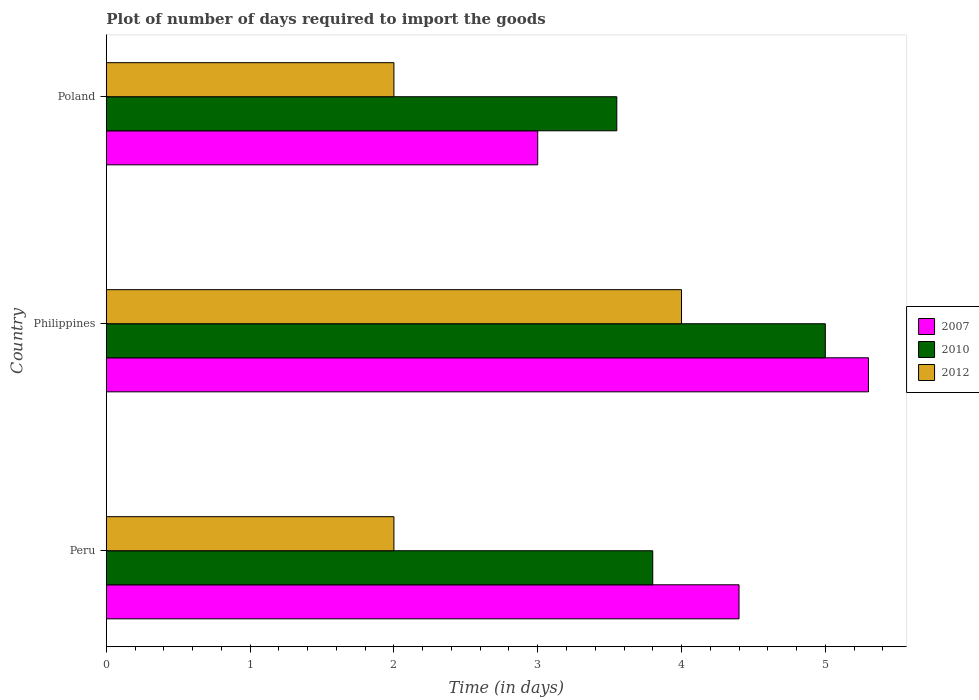How many different coloured bars are there?
Offer a terse response. 3. Are the number of bars per tick equal to the number of legend labels?
Your response must be concise. Yes. Are the number of bars on each tick of the Y-axis equal?
Your answer should be compact. Yes. What is the label of the 2nd group of bars from the top?
Offer a terse response. Philippines. Across all countries, what is the minimum time required to import goods in 2012?
Offer a terse response. 2. In which country was the time required to import goods in 2012 maximum?
Provide a succinct answer. Philippines. In which country was the time required to import goods in 2012 minimum?
Keep it short and to the point. Peru. What is the total time required to import goods in 2010 in the graph?
Your answer should be compact. 12.35. What is the difference between the time required to import goods in 2010 in Philippines and that in Poland?
Keep it short and to the point. 1.45. What is the average time required to import goods in 2012 per country?
Ensure brevity in your answer.  2.67. What is the difference between the time required to import goods in 2007 and time required to import goods in 2010 in Poland?
Your answer should be compact. -0.55. Is the difference between the time required to import goods in 2007 in Philippines and Poland greater than the difference between the time required to import goods in 2010 in Philippines and Poland?
Your answer should be very brief. Yes. What is the difference between the highest and the second highest time required to import goods in 2012?
Your answer should be compact. 2. What is the difference between the highest and the lowest time required to import goods in 2010?
Keep it short and to the point. 1.45. In how many countries, is the time required to import goods in 2012 greater than the average time required to import goods in 2012 taken over all countries?
Make the answer very short. 1. Is the sum of the time required to import goods in 2012 in Peru and Philippines greater than the maximum time required to import goods in 2010 across all countries?
Make the answer very short. Yes. What does the 1st bar from the bottom in Peru represents?
Your answer should be compact. 2007. Is it the case that in every country, the sum of the time required to import goods in 2012 and time required to import goods in 2007 is greater than the time required to import goods in 2010?
Offer a terse response. Yes. How many bars are there?
Give a very brief answer. 9. What is the difference between two consecutive major ticks on the X-axis?
Keep it short and to the point. 1. Are the values on the major ticks of X-axis written in scientific E-notation?
Your answer should be compact. No. How many legend labels are there?
Offer a very short reply. 3. How are the legend labels stacked?
Keep it short and to the point. Vertical. What is the title of the graph?
Your answer should be compact. Plot of number of days required to import the goods. Does "1980" appear as one of the legend labels in the graph?
Your response must be concise. No. What is the label or title of the X-axis?
Keep it short and to the point. Time (in days). What is the Time (in days) in 2012 in Peru?
Offer a very short reply. 2. What is the Time (in days) of 2010 in Philippines?
Keep it short and to the point. 5. What is the Time (in days) in 2007 in Poland?
Ensure brevity in your answer.  3. What is the Time (in days) in 2010 in Poland?
Provide a succinct answer. 3.55. What is the Time (in days) of 2012 in Poland?
Your answer should be very brief. 2. Across all countries, what is the maximum Time (in days) of 2007?
Provide a short and direct response. 5.3. Across all countries, what is the maximum Time (in days) of 2010?
Your response must be concise. 5. Across all countries, what is the maximum Time (in days) in 2012?
Ensure brevity in your answer.  4. Across all countries, what is the minimum Time (in days) of 2010?
Your answer should be very brief. 3.55. Across all countries, what is the minimum Time (in days) of 2012?
Ensure brevity in your answer.  2. What is the total Time (in days) in 2007 in the graph?
Keep it short and to the point. 12.7. What is the total Time (in days) of 2010 in the graph?
Offer a very short reply. 12.35. What is the total Time (in days) of 2012 in the graph?
Make the answer very short. 8. What is the difference between the Time (in days) of 2010 in Peru and that in Philippines?
Your response must be concise. -1.2. What is the difference between the Time (in days) of 2010 in Peru and that in Poland?
Provide a succinct answer. 0.25. What is the difference between the Time (in days) in 2007 in Philippines and that in Poland?
Your response must be concise. 2.3. What is the difference between the Time (in days) of 2010 in Philippines and that in Poland?
Your response must be concise. 1.45. What is the difference between the Time (in days) of 2012 in Philippines and that in Poland?
Provide a succinct answer. 2. What is the difference between the Time (in days) in 2007 in Peru and the Time (in days) in 2010 in Philippines?
Your answer should be compact. -0.6. What is the difference between the Time (in days) of 2007 in Peru and the Time (in days) of 2010 in Poland?
Provide a succinct answer. 0.85. What is the difference between the Time (in days) in 2010 in Peru and the Time (in days) in 2012 in Poland?
Provide a succinct answer. 1.8. What is the difference between the Time (in days) in 2007 in Philippines and the Time (in days) in 2010 in Poland?
Offer a very short reply. 1.75. What is the difference between the Time (in days) in 2010 in Philippines and the Time (in days) in 2012 in Poland?
Offer a very short reply. 3. What is the average Time (in days) in 2007 per country?
Give a very brief answer. 4.23. What is the average Time (in days) of 2010 per country?
Your answer should be very brief. 4.12. What is the average Time (in days) in 2012 per country?
Give a very brief answer. 2.67. What is the difference between the Time (in days) in 2010 and Time (in days) in 2012 in Peru?
Ensure brevity in your answer.  1.8. What is the difference between the Time (in days) in 2007 and Time (in days) in 2010 in Poland?
Make the answer very short. -0.55. What is the difference between the Time (in days) in 2010 and Time (in days) in 2012 in Poland?
Your response must be concise. 1.55. What is the ratio of the Time (in days) of 2007 in Peru to that in Philippines?
Ensure brevity in your answer.  0.83. What is the ratio of the Time (in days) in 2010 in Peru to that in Philippines?
Offer a very short reply. 0.76. What is the ratio of the Time (in days) of 2012 in Peru to that in Philippines?
Give a very brief answer. 0.5. What is the ratio of the Time (in days) of 2007 in Peru to that in Poland?
Provide a short and direct response. 1.47. What is the ratio of the Time (in days) of 2010 in Peru to that in Poland?
Ensure brevity in your answer.  1.07. What is the ratio of the Time (in days) of 2007 in Philippines to that in Poland?
Provide a succinct answer. 1.77. What is the ratio of the Time (in days) in 2010 in Philippines to that in Poland?
Keep it short and to the point. 1.41. What is the ratio of the Time (in days) in 2012 in Philippines to that in Poland?
Your response must be concise. 2. What is the difference between the highest and the second highest Time (in days) of 2007?
Ensure brevity in your answer.  0.9. What is the difference between the highest and the second highest Time (in days) of 2012?
Keep it short and to the point. 2. What is the difference between the highest and the lowest Time (in days) in 2007?
Offer a very short reply. 2.3. What is the difference between the highest and the lowest Time (in days) in 2010?
Make the answer very short. 1.45. 